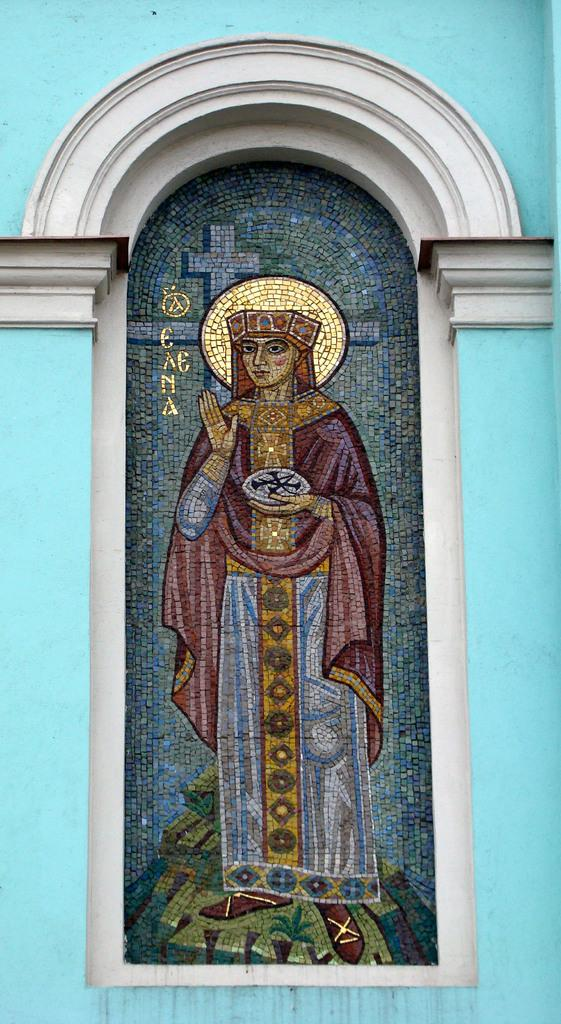What type of structure can be seen in the image? There is a wall in the image. Is there any opening in the wall? Yes, there is a window in the image. What is depicted on the glass of the window? There is a painting of a person on the glass of the window. Are there any words or letters on the glass of the window? Yes, there is text visible on the glass of the window. What type of pest can be seen crawling on the painting of the person in the image? There are no pests visible in the image; the painting of the person is on the glass of the window. 